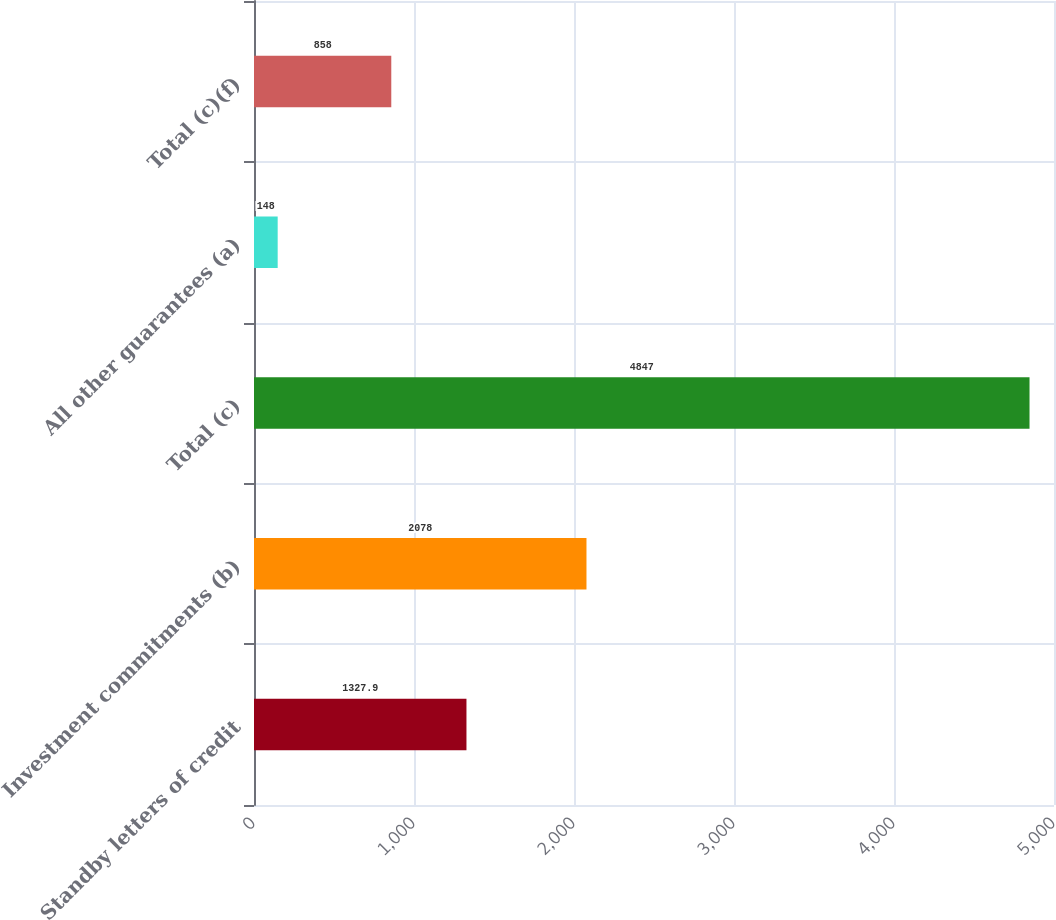<chart> <loc_0><loc_0><loc_500><loc_500><bar_chart><fcel>Standby letters of credit<fcel>Investment commitments (b)<fcel>Total (c)<fcel>All other guarantees (a)<fcel>Total (c)(f)<nl><fcel>1327.9<fcel>2078<fcel>4847<fcel>148<fcel>858<nl></chart> 